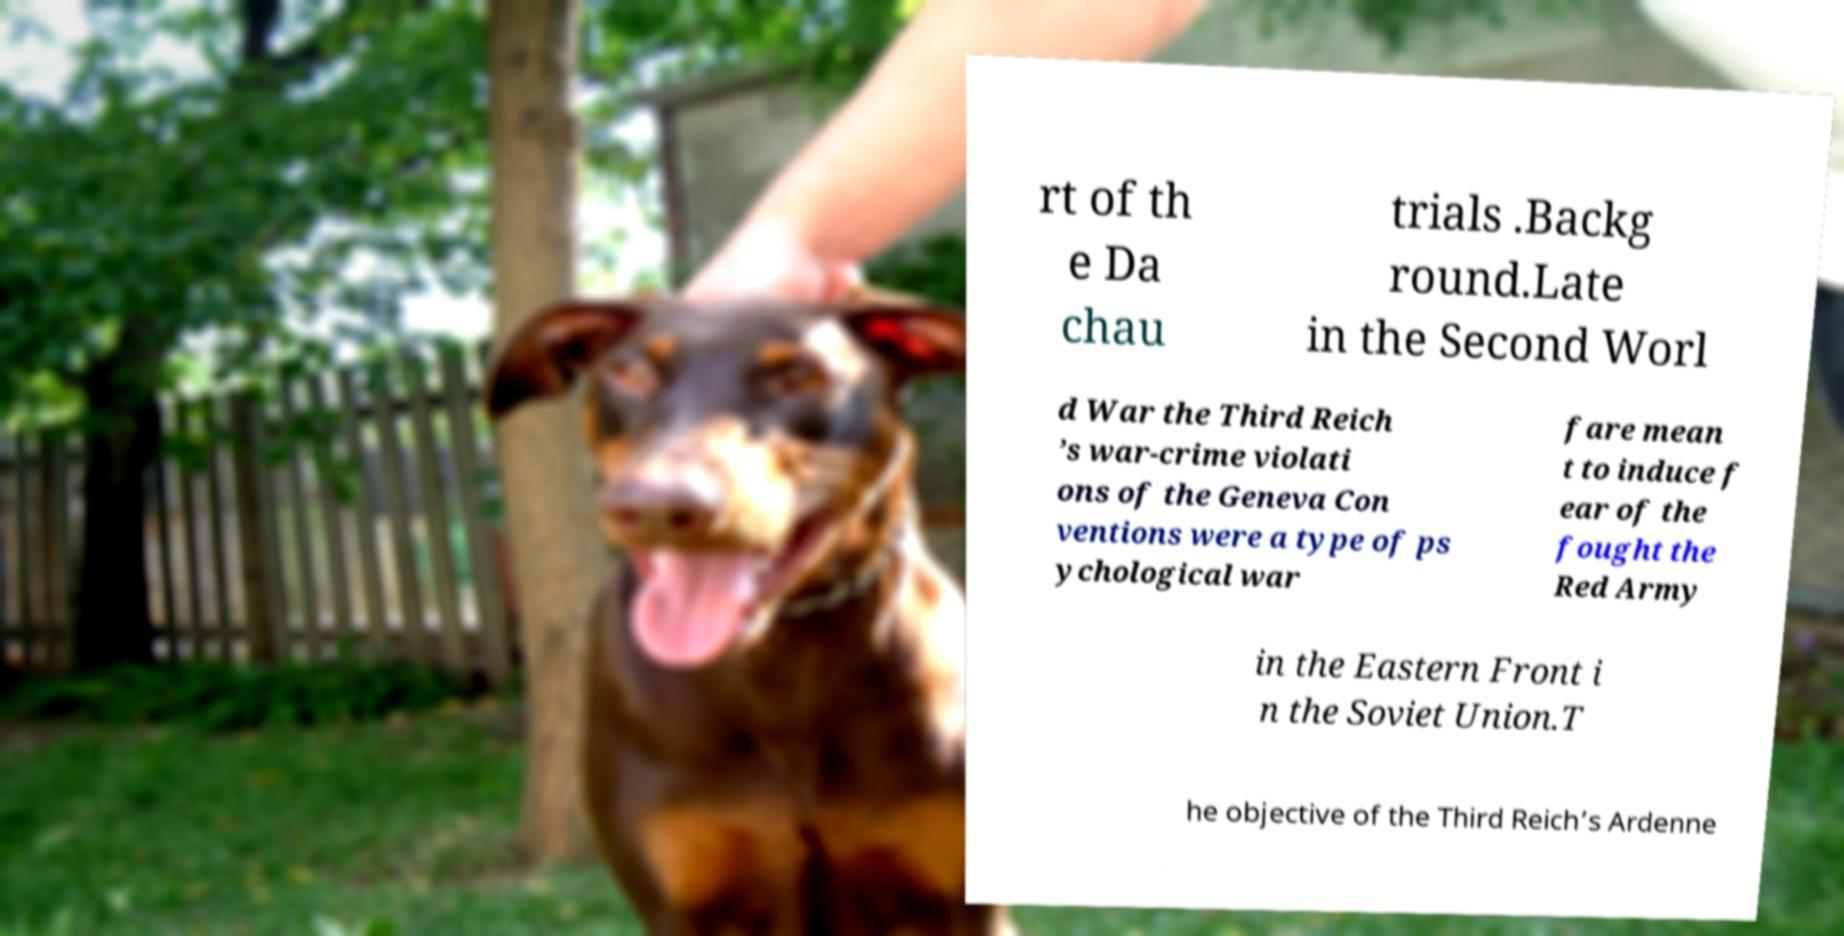Could you extract and type out the text from this image? rt of th e Da chau trials .Backg round.Late in the Second Worl d War the Third Reich ’s war-crime violati ons of the Geneva Con ventions were a type of ps ychological war fare mean t to induce f ear of the fought the Red Army in the Eastern Front i n the Soviet Union.T he objective of the Third Reich’s Ardenne 